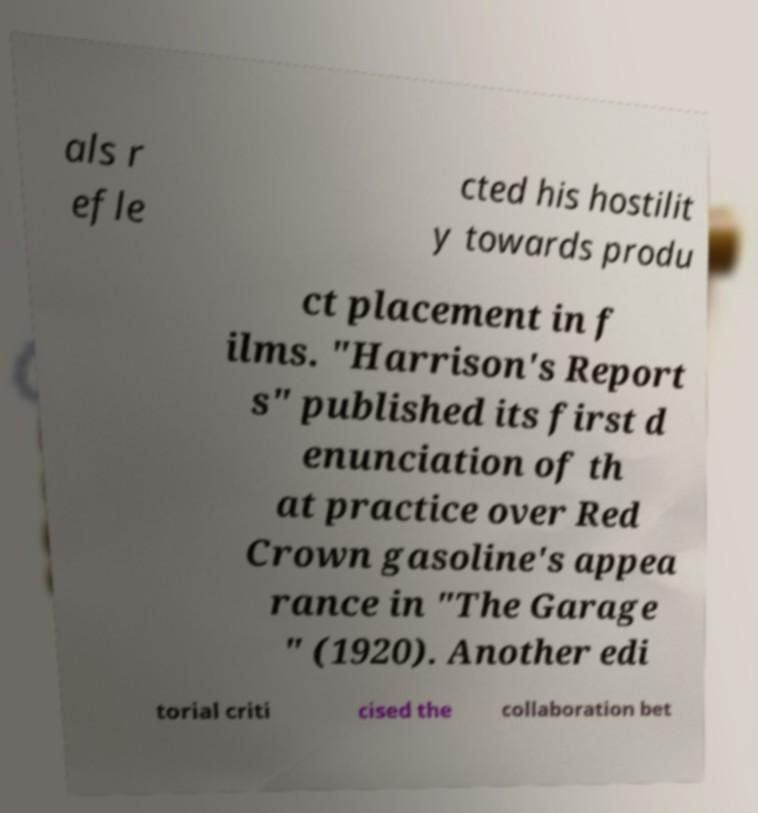Please read and relay the text visible in this image. What does it say? als r efle cted his hostilit y towards produ ct placement in f ilms. "Harrison's Report s" published its first d enunciation of th at practice over Red Crown gasoline's appea rance in "The Garage " (1920). Another edi torial criti cised the collaboration bet 